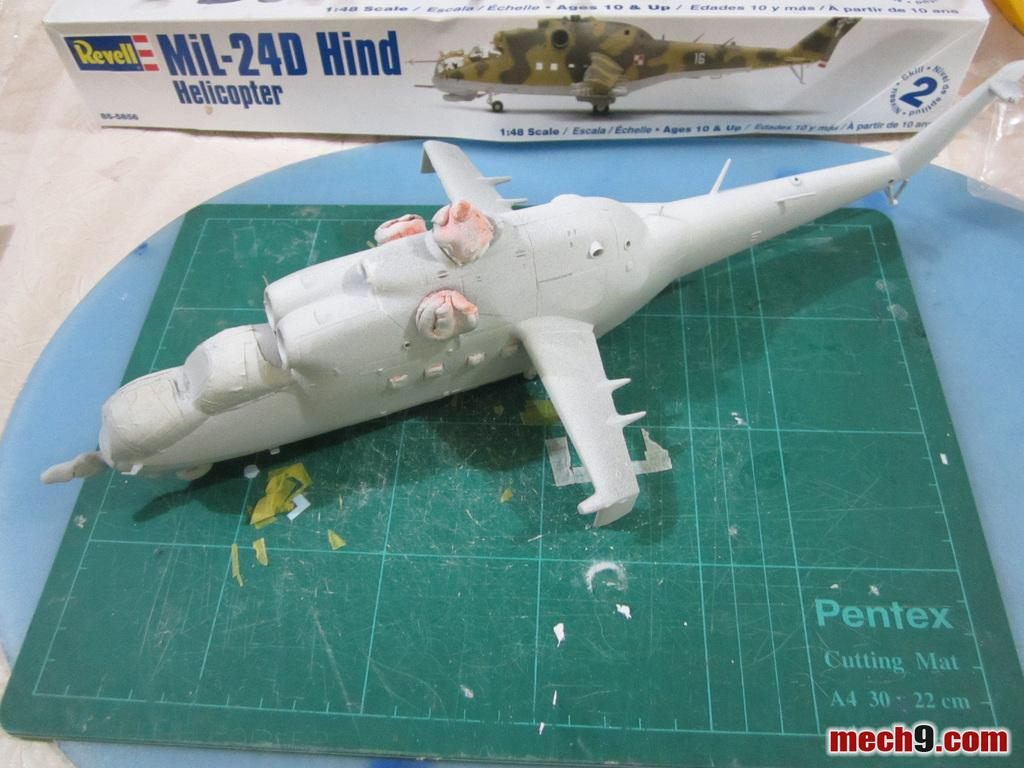<image>
Create a compact narrative representing the image presented. Mech9.com shows an image of a model airplane in progress. 